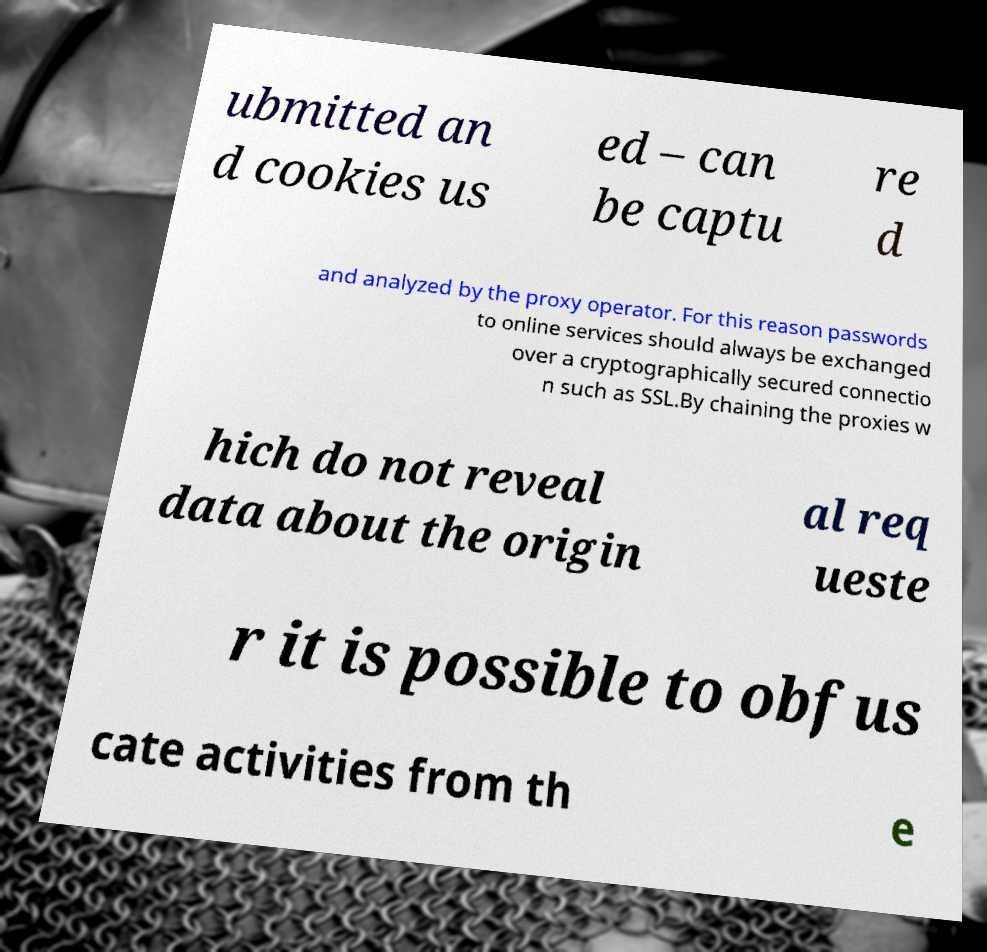Could you assist in decoding the text presented in this image and type it out clearly? ubmitted an d cookies us ed – can be captu re d and analyzed by the proxy operator. For this reason passwords to online services should always be exchanged over a cryptographically secured connectio n such as SSL.By chaining the proxies w hich do not reveal data about the origin al req ueste r it is possible to obfus cate activities from th e 